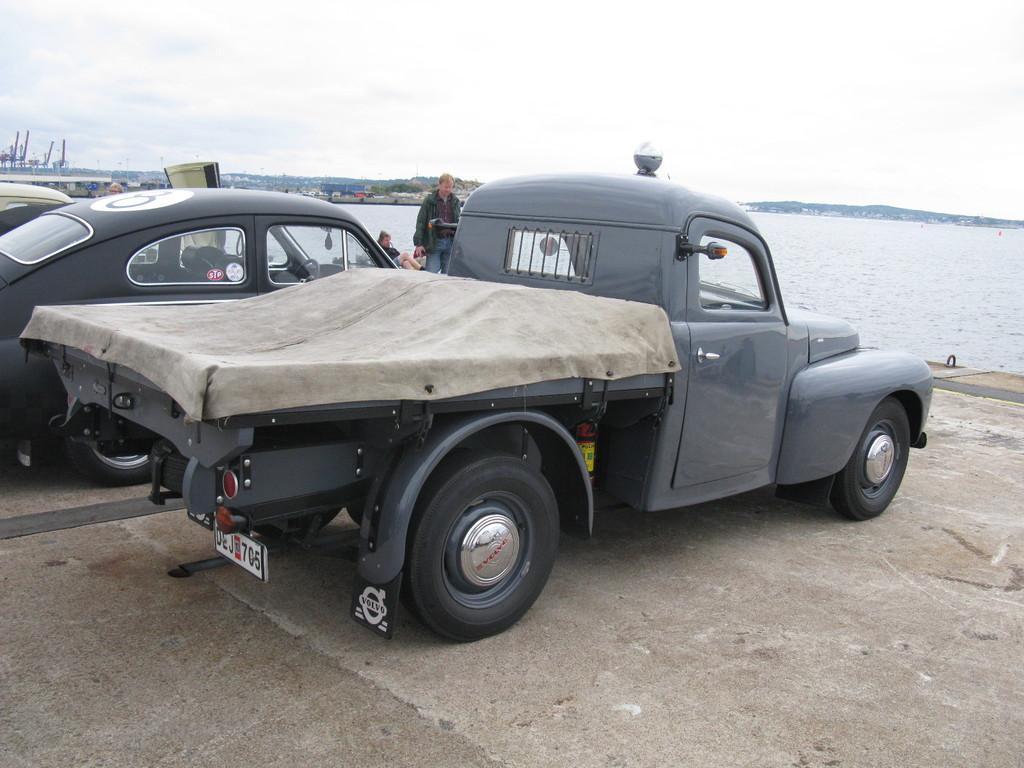Describe this image in one or two sentences. In this image there are vehicles. In front of the vehicles there are people. In the background of the image there is water. There are trees, buildings, mountains and sky. 